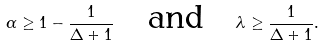Convert formula to latex. <formula><loc_0><loc_0><loc_500><loc_500>\alpha \geq 1 - \frac { 1 } { \Delta + 1 } \quad \text {and} \quad \lambda \geq \frac { 1 } { \Delta + 1 } .</formula> 